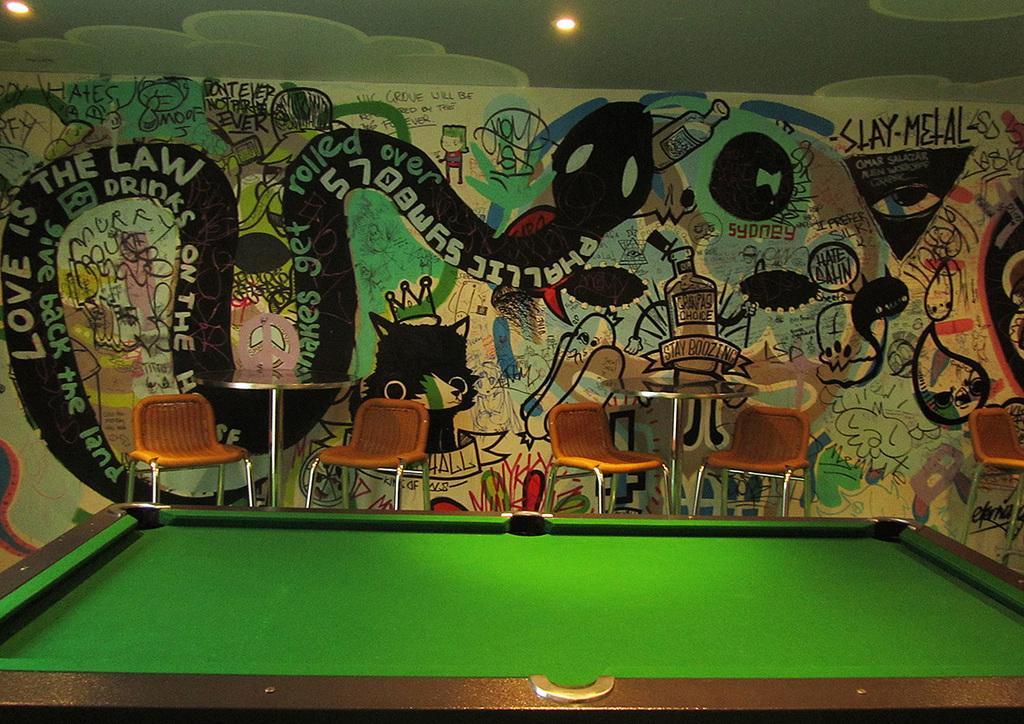Describe this image in one or two sentences. In the center we can see tables and chairs. In the front bottom we can see the table. And coming to the background we can see the wall. 